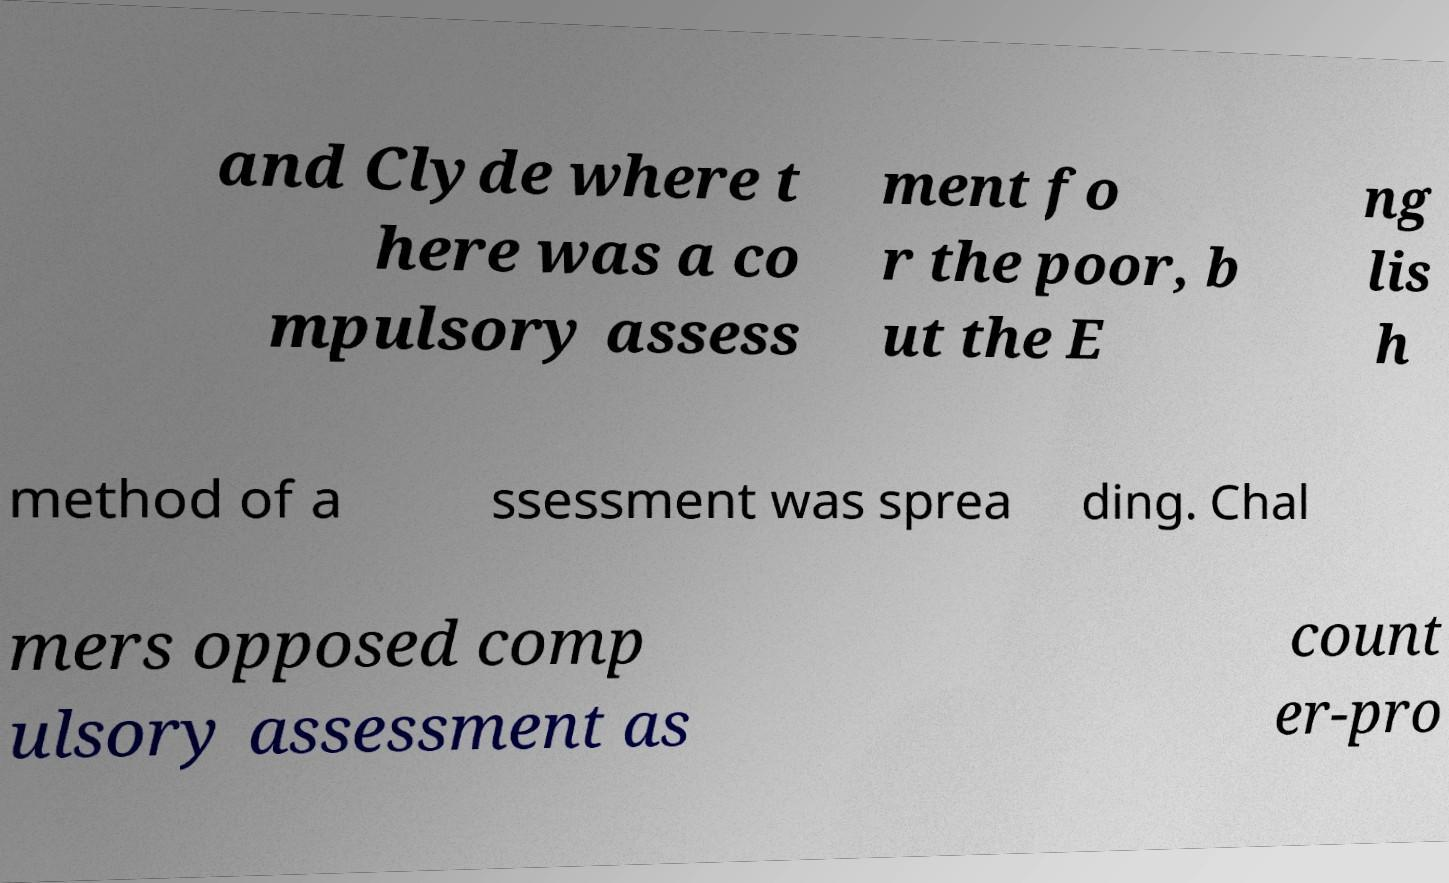There's text embedded in this image that I need extracted. Can you transcribe it verbatim? and Clyde where t here was a co mpulsory assess ment fo r the poor, b ut the E ng lis h method of a ssessment was sprea ding. Chal mers opposed comp ulsory assessment as count er-pro 